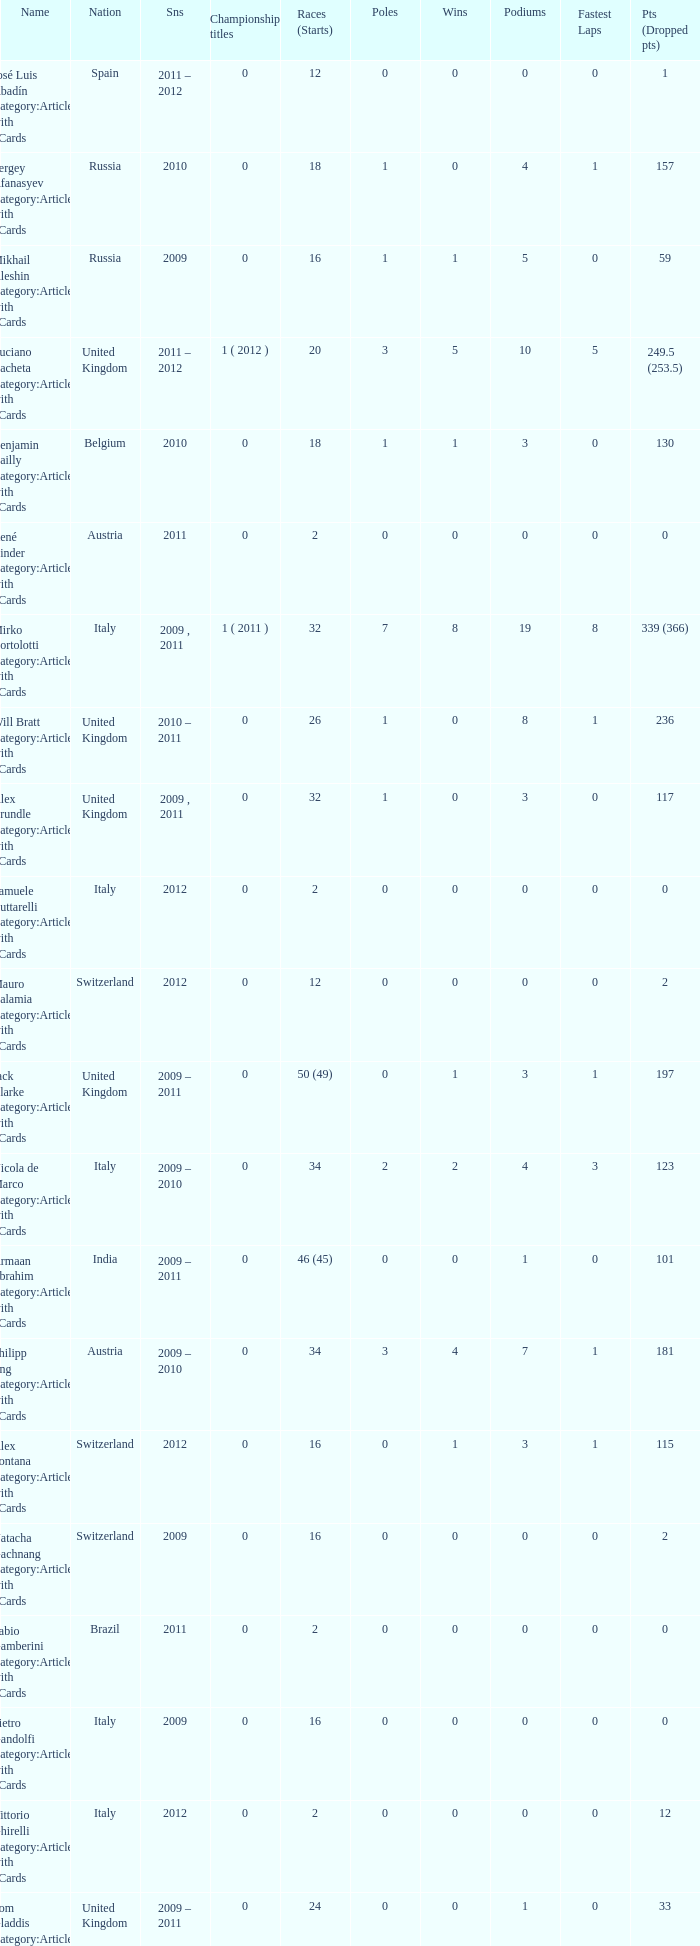What were the starts when the points dropped 18? 8.0. 